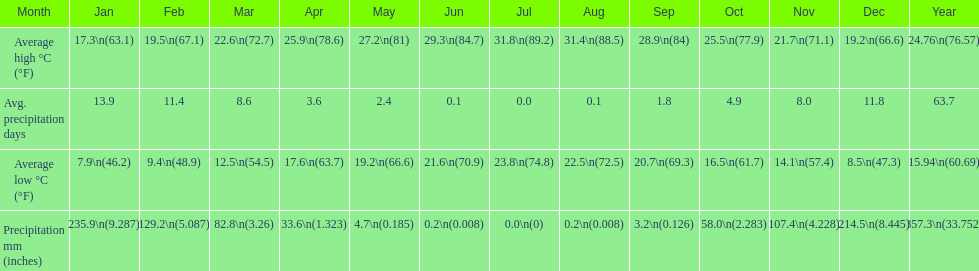What is the month with the lowest average low in haifa? January. 